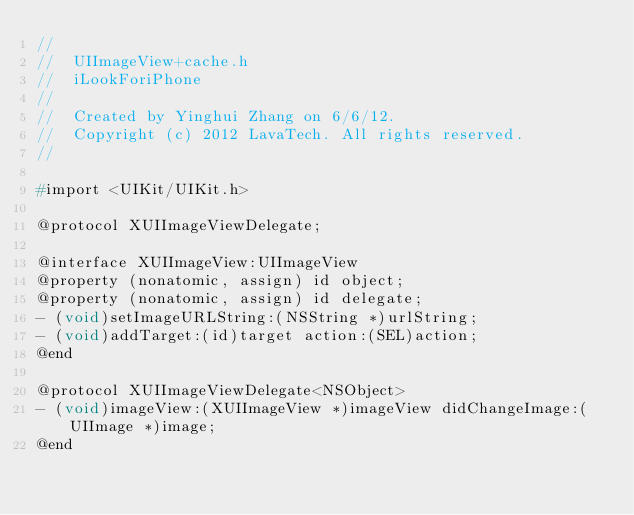Convert code to text. <code><loc_0><loc_0><loc_500><loc_500><_C_>//
//  UIImageView+cache.h
//  iLookForiPhone
//
//  Created by Yinghui Zhang on 6/6/12.
//  Copyright (c) 2012 LavaTech. All rights reserved.
//

#import <UIKit/UIKit.h>

@protocol XUIImageViewDelegate;

@interface XUIImageView:UIImageView
@property (nonatomic, assign) id object;
@property (nonatomic, assign) id delegate;
- (void)setImageURLString:(NSString *)urlString;
- (void)addTarget:(id)target action:(SEL)action;
@end

@protocol XUIImageViewDelegate<NSObject>
- (void)imageView:(XUIImageView *)imageView didChangeImage:(UIImage *)image;
@end</code> 